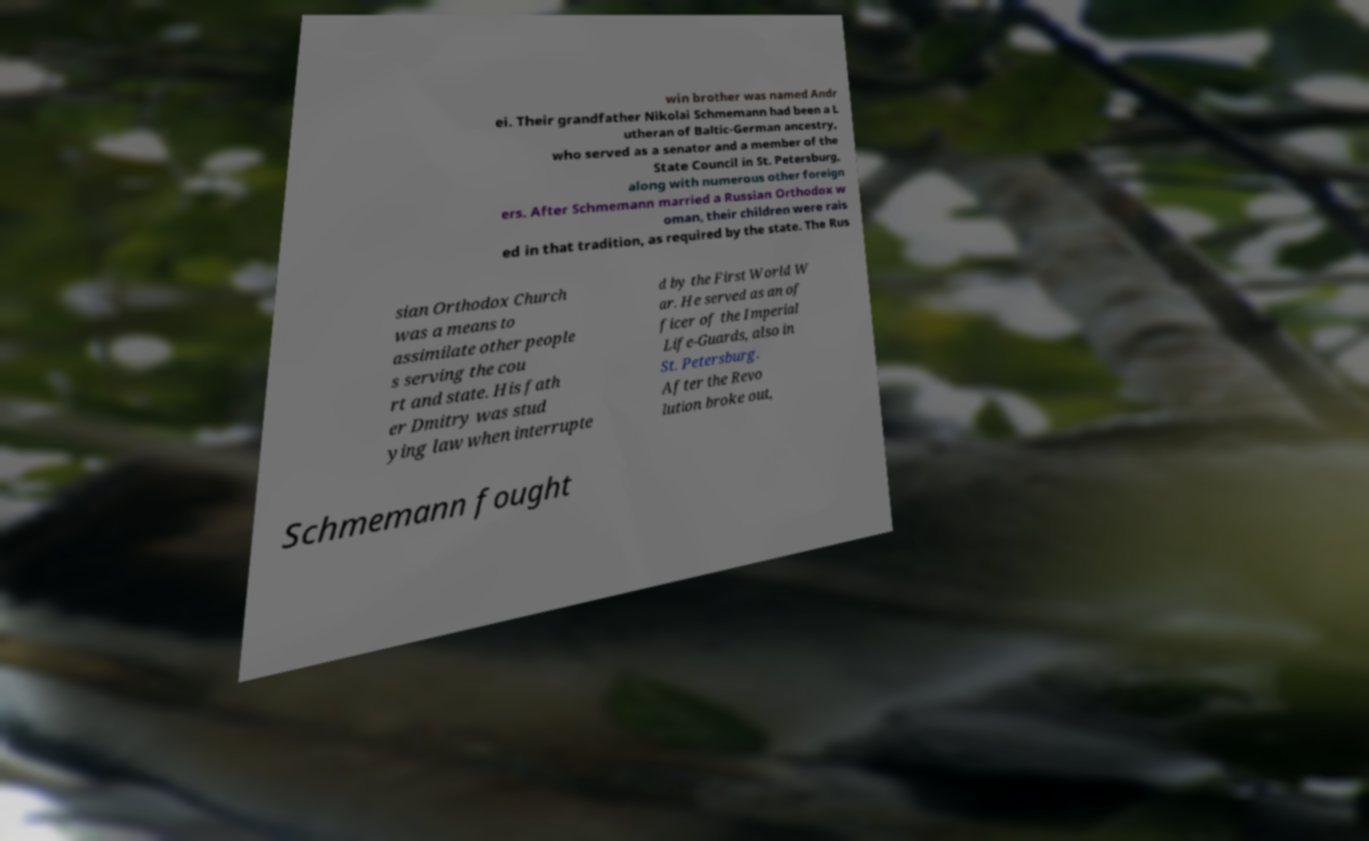I need the written content from this picture converted into text. Can you do that? win brother was named Andr ei. Their grandfather Nikolai Schmemann had been a L utheran of Baltic-German ancestry, who served as a senator and a member of the State Council in St. Petersburg, along with numerous other foreign ers. After Schmemann married a Russian Orthodox w oman, their children were rais ed in that tradition, as required by the state. The Rus sian Orthodox Church was a means to assimilate other people s serving the cou rt and state. His fath er Dmitry was stud ying law when interrupte d by the First World W ar. He served as an of ficer of the Imperial Life-Guards, also in St. Petersburg. After the Revo lution broke out, Schmemann fought 